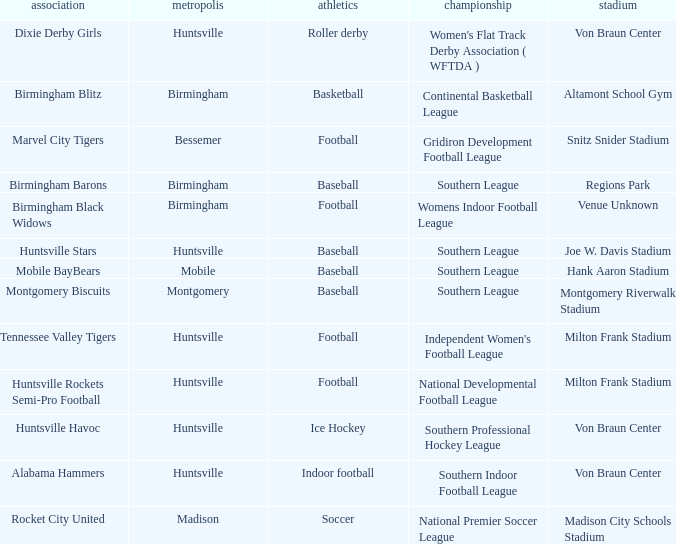Which sport was held in Huntsville at the Von Braun Center as part of the Southern Indoor Football League? Indoor football. 